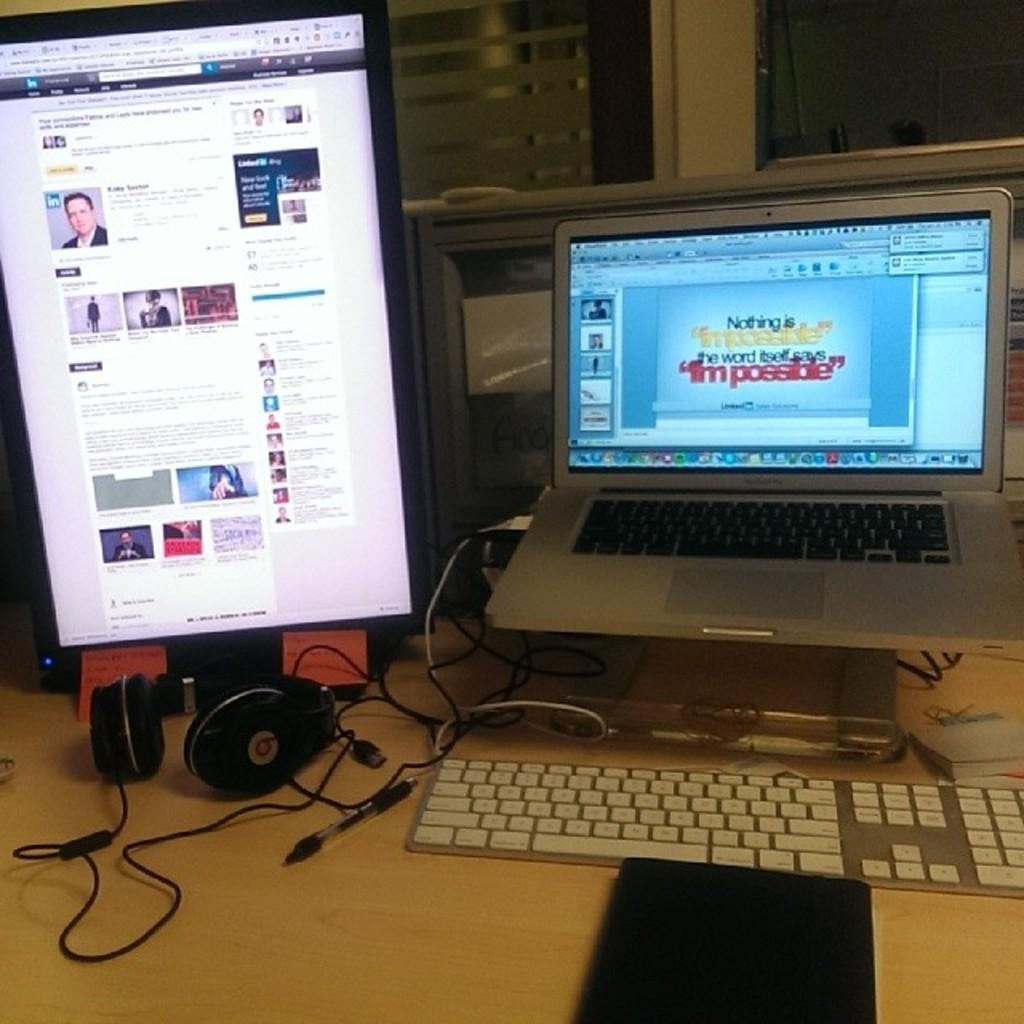<image>
Relay a brief, clear account of the picture shown. Someone is preparing a laptop presentation with motivational text about what is possible. 